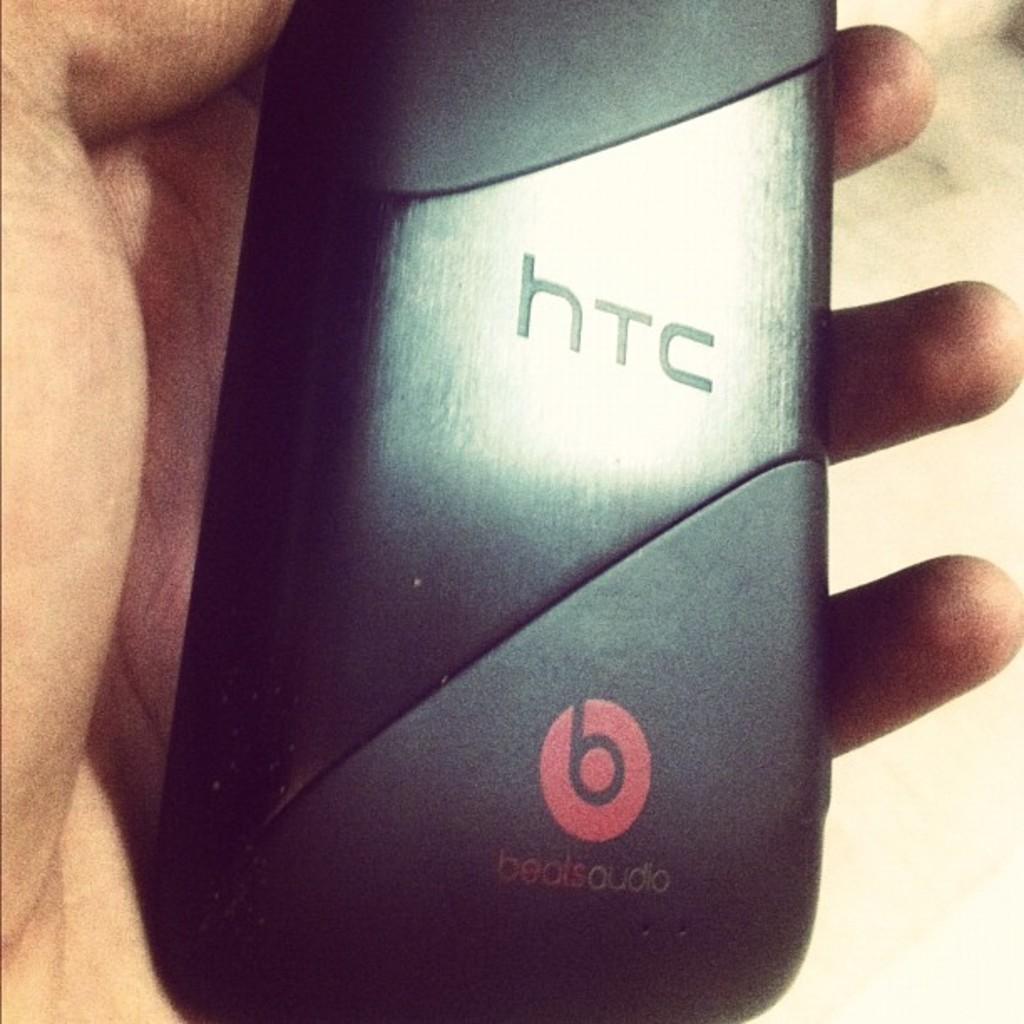What brand of phone is this?
Provide a short and direct response. Htc. What logo is on the bottom right?
Provide a succinct answer. Beats audio. 